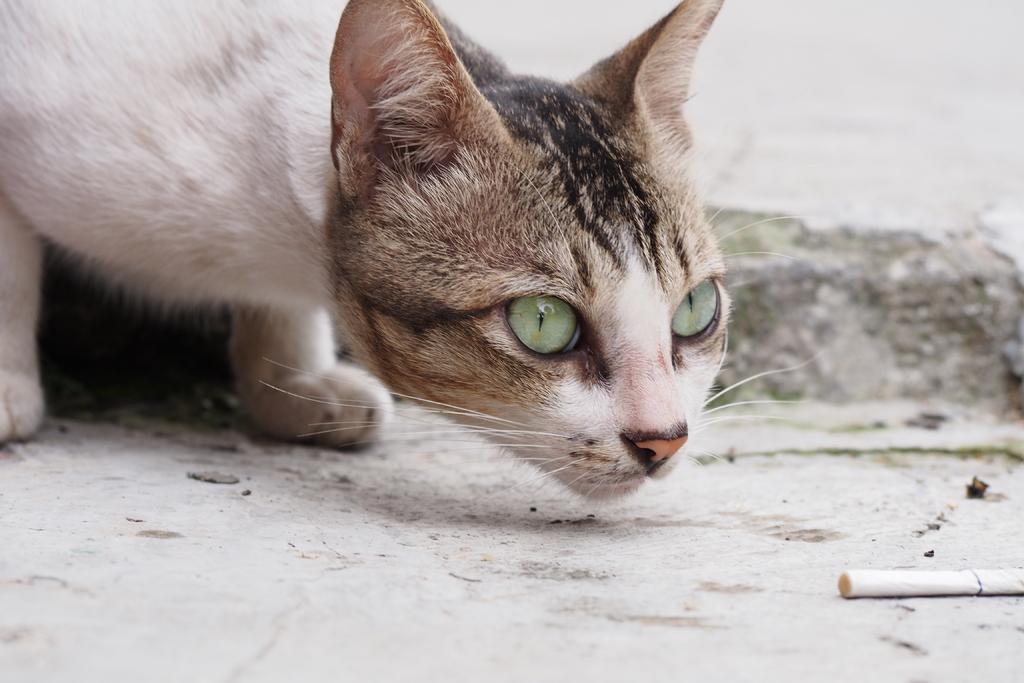In one or two sentences, can you explain what this image depicts? In this image we can see a cat and a cigarette on the floor. 